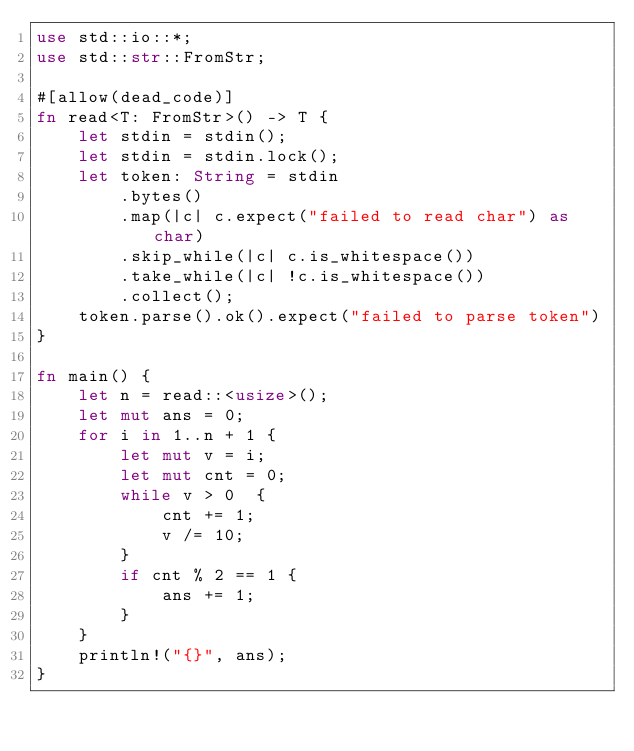<code> <loc_0><loc_0><loc_500><loc_500><_Rust_>use std::io::*;
use std::str::FromStr;

#[allow(dead_code)]
fn read<T: FromStr>() -> T {
    let stdin = stdin();
    let stdin = stdin.lock();
    let token: String = stdin
        .bytes()
        .map(|c| c.expect("failed to read char") as char)
        .skip_while(|c| c.is_whitespace())
        .take_while(|c| !c.is_whitespace())
        .collect();
    token.parse().ok().expect("failed to parse token")
}

fn main() {
    let n = read::<usize>();
    let mut ans = 0;
    for i in 1..n + 1 {
        let mut v = i;
        let mut cnt = 0;
        while v > 0  {
            cnt += 1;
            v /= 10;
        }
        if cnt % 2 == 1 {
            ans += 1;
        }
    }
    println!("{}", ans);
}
</code> 